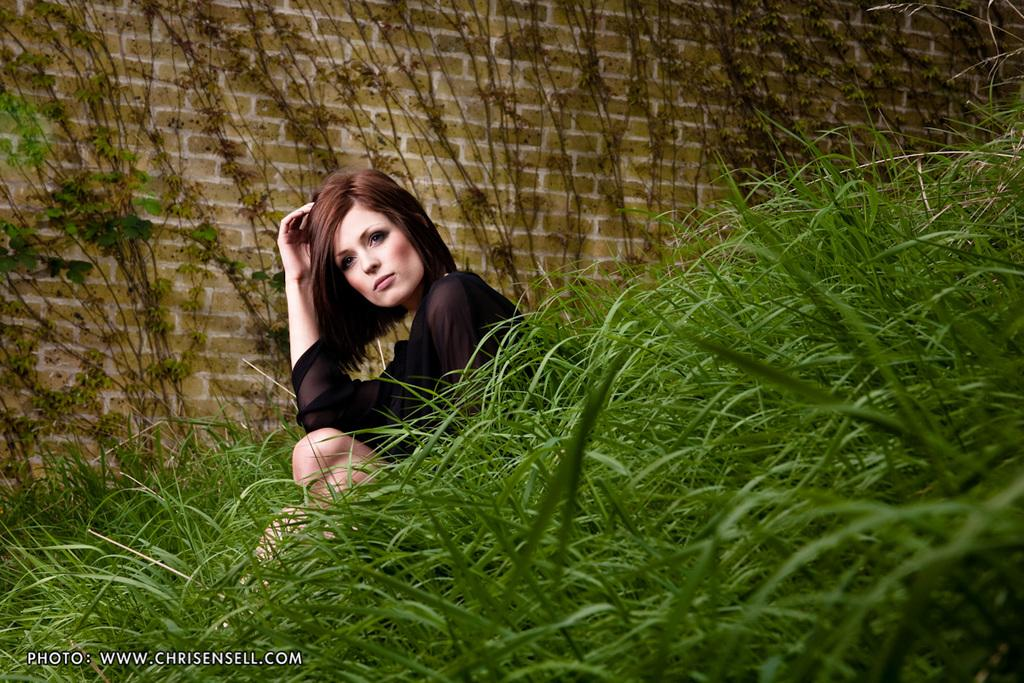Who is present in the image? There is a woman in the image. What is the woman wearing? The woman is wearing a black dress. What type of natural environment can be seen in the image? There is grass visible in the image. What type of structure is visible in the background? There is a brick wall in the background of the image. Reasoning: Let' Let's think step by step in order to produce the conversation. We start by identifying the main subject in the image, which is the woman. Then, we describe her clothing to provide more detail about her appearance. Next, we mention the natural environment visible in the image, which is the grass. Finally, we describe the background structure, which is the brick wall. Each question is designed to elicit a specific detail about the image that is known from the provided facts. Absurd Question/Answer: What type of instrument is the woman playing in the image? There is no instrument present in the image, and the woman is not playing any instrument. What type of debt is the woman discussing with the shop owner in the image? There is no shop owner or discussion of debt present in the image. The woman is simply standing in front of a brick wall, wearing a black dress. 